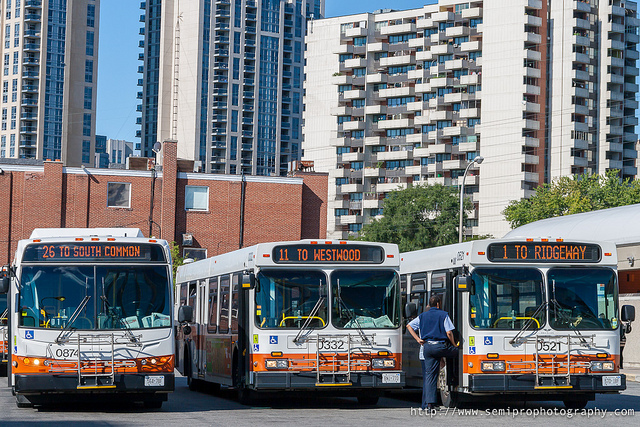Identify and read out the text in this image. WESTWOOD RIDGEWAY 11 0332 0521 http://www.semiprophotography.com 0874 TO 1 TO COMMON SOUTH TO 26 